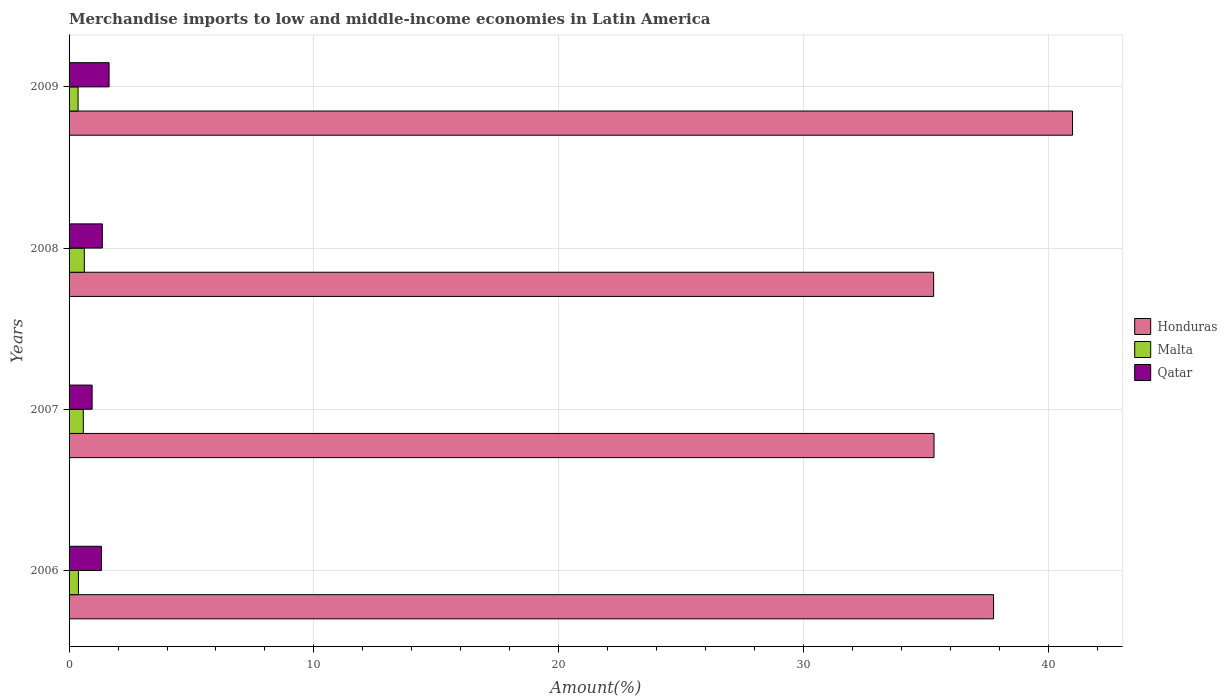How many different coloured bars are there?
Offer a terse response. 3. How many groups of bars are there?
Keep it short and to the point. 4. Are the number of bars per tick equal to the number of legend labels?
Keep it short and to the point. Yes. Are the number of bars on each tick of the Y-axis equal?
Provide a succinct answer. Yes. How many bars are there on the 3rd tick from the top?
Your answer should be very brief. 3. How many bars are there on the 3rd tick from the bottom?
Provide a short and direct response. 3. In how many cases, is the number of bars for a given year not equal to the number of legend labels?
Make the answer very short. 0. What is the percentage of amount earned from merchandise imports in Honduras in 2009?
Your answer should be very brief. 40.98. Across all years, what is the maximum percentage of amount earned from merchandise imports in Qatar?
Ensure brevity in your answer.  1.63. Across all years, what is the minimum percentage of amount earned from merchandise imports in Qatar?
Your response must be concise. 0.94. In which year was the percentage of amount earned from merchandise imports in Malta maximum?
Offer a terse response. 2008. In which year was the percentage of amount earned from merchandise imports in Qatar minimum?
Your answer should be very brief. 2007. What is the total percentage of amount earned from merchandise imports in Honduras in the graph?
Your answer should be very brief. 149.37. What is the difference between the percentage of amount earned from merchandise imports in Malta in 2007 and that in 2009?
Your response must be concise. 0.21. What is the difference between the percentage of amount earned from merchandise imports in Honduras in 2006 and the percentage of amount earned from merchandise imports in Malta in 2009?
Offer a terse response. 37.39. What is the average percentage of amount earned from merchandise imports in Qatar per year?
Your answer should be very brief. 1.31. In the year 2007, what is the difference between the percentage of amount earned from merchandise imports in Honduras and percentage of amount earned from merchandise imports in Qatar?
Offer a terse response. 34.38. In how many years, is the percentage of amount earned from merchandise imports in Malta greater than 26 %?
Ensure brevity in your answer.  0. What is the ratio of the percentage of amount earned from merchandise imports in Honduras in 2006 to that in 2007?
Provide a succinct answer. 1.07. What is the difference between the highest and the second highest percentage of amount earned from merchandise imports in Honduras?
Provide a short and direct response. 3.22. What is the difference between the highest and the lowest percentage of amount earned from merchandise imports in Malta?
Provide a short and direct response. 0.26. In how many years, is the percentage of amount earned from merchandise imports in Qatar greater than the average percentage of amount earned from merchandise imports in Qatar taken over all years?
Your response must be concise. 3. What does the 3rd bar from the top in 2006 represents?
Provide a succinct answer. Honduras. What does the 1st bar from the bottom in 2007 represents?
Provide a short and direct response. Honduras. How many years are there in the graph?
Provide a short and direct response. 4. Does the graph contain grids?
Ensure brevity in your answer.  Yes. Where does the legend appear in the graph?
Make the answer very short. Center right. What is the title of the graph?
Provide a short and direct response. Merchandise imports to low and middle-income economies in Latin America. Does "United States" appear as one of the legend labels in the graph?
Your answer should be compact. No. What is the label or title of the X-axis?
Offer a terse response. Amount(%). What is the Amount(%) of Honduras in 2006?
Ensure brevity in your answer.  37.76. What is the Amount(%) of Malta in 2006?
Your response must be concise. 0.38. What is the Amount(%) of Qatar in 2006?
Your answer should be very brief. 1.32. What is the Amount(%) in Honduras in 2007?
Ensure brevity in your answer.  35.32. What is the Amount(%) in Malta in 2007?
Your answer should be very brief. 0.58. What is the Amount(%) of Qatar in 2007?
Give a very brief answer. 0.94. What is the Amount(%) of Honduras in 2008?
Provide a succinct answer. 35.31. What is the Amount(%) in Malta in 2008?
Give a very brief answer. 0.62. What is the Amount(%) of Qatar in 2008?
Give a very brief answer. 1.36. What is the Amount(%) of Honduras in 2009?
Your response must be concise. 40.98. What is the Amount(%) of Malta in 2009?
Keep it short and to the point. 0.37. What is the Amount(%) in Qatar in 2009?
Give a very brief answer. 1.63. Across all years, what is the maximum Amount(%) in Honduras?
Offer a very short reply. 40.98. Across all years, what is the maximum Amount(%) of Malta?
Your response must be concise. 0.62. Across all years, what is the maximum Amount(%) in Qatar?
Give a very brief answer. 1.63. Across all years, what is the minimum Amount(%) in Honduras?
Your answer should be compact. 35.31. Across all years, what is the minimum Amount(%) of Malta?
Offer a very short reply. 0.37. Across all years, what is the minimum Amount(%) of Qatar?
Offer a terse response. 0.94. What is the total Amount(%) of Honduras in the graph?
Give a very brief answer. 149.37. What is the total Amount(%) in Malta in the graph?
Provide a short and direct response. 1.95. What is the total Amount(%) in Qatar in the graph?
Provide a short and direct response. 5.26. What is the difference between the Amount(%) in Honduras in 2006 and that in 2007?
Offer a very short reply. 2.43. What is the difference between the Amount(%) in Malta in 2006 and that in 2007?
Ensure brevity in your answer.  -0.2. What is the difference between the Amount(%) in Qatar in 2006 and that in 2007?
Make the answer very short. 0.38. What is the difference between the Amount(%) of Honduras in 2006 and that in 2008?
Your answer should be compact. 2.45. What is the difference between the Amount(%) in Malta in 2006 and that in 2008?
Your answer should be very brief. -0.24. What is the difference between the Amount(%) in Qatar in 2006 and that in 2008?
Your answer should be very brief. -0.04. What is the difference between the Amount(%) in Honduras in 2006 and that in 2009?
Your response must be concise. -3.22. What is the difference between the Amount(%) of Malta in 2006 and that in 2009?
Your answer should be very brief. 0.01. What is the difference between the Amount(%) of Qatar in 2006 and that in 2009?
Make the answer very short. -0.31. What is the difference between the Amount(%) in Honduras in 2007 and that in 2008?
Your answer should be compact. 0.02. What is the difference between the Amount(%) of Malta in 2007 and that in 2008?
Provide a short and direct response. -0.04. What is the difference between the Amount(%) in Qatar in 2007 and that in 2008?
Keep it short and to the point. -0.42. What is the difference between the Amount(%) of Honduras in 2007 and that in 2009?
Your answer should be compact. -5.66. What is the difference between the Amount(%) of Malta in 2007 and that in 2009?
Provide a short and direct response. 0.21. What is the difference between the Amount(%) of Qatar in 2007 and that in 2009?
Your answer should be compact. -0.69. What is the difference between the Amount(%) in Honduras in 2008 and that in 2009?
Your answer should be very brief. -5.67. What is the difference between the Amount(%) in Malta in 2008 and that in 2009?
Provide a short and direct response. 0.26. What is the difference between the Amount(%) of Qatar in 2008 and that in 2009?
Give a very brief answer. -0.28. What is the difference between the Amount(%) in Honduras in 2006 and the Amount(%) in Malta in 2007?
Give a very brief answer. 37.17. What is the difference between the Amount(%) in Honduras in 2006 and the Amount(%) in Qatar in 2007?
Your response must be concise. 36.81. What is the difference between the Amount(%) of Malta in 2006 and the Amount(%) of Qatar in 2007?
Keep it short and to the point. -0.56. What is the difference between the Amount(%) of Honduras in 2006 and the Amount(%) of Malta in 2008?
Offer a terse response. 37.13. What is the difference between the Amount(%) in Honduras in 2006 and the Amount(%) in Qatar in 2008?
Offer a very short reply. 36.4. What is the difference between the Amount(%) in Malta in 2006 and the Amount(%) in Qatar in 2008?
Ensure brevity in your answer.  -0.98. What is the difference between the Amount(%) of Honduras in 2006 and the Amount(%) of Malta in 2009?
Provide a succinct answer. 37.39. What is the difference between the Amount(%) in Honduras in 2006 and the Amount(%) in Qatar in 2009?
Offer a terse response. 36.12. What is the difference between the Amount(%) of Malta in 2006 and the Amount(%) of Qatar in 2009?
Ensure brevity in your answer.  -1.25. What is the difference between the Amount(%) in Honduras in 2007 and the Amount(%) in Malta in 2008?
Offer a very short reply. 34.7. What is the difference between the Amount(%) in Honduras in 2007 and the Amount(%) in Qatar in 2008?
Provide a succinct answer. 33.97. What is the difference between the Amount(%) in Malta in 2007 and the Amount(%) in Qatar in 2008?
Your answer should be very brief. -0.78. What is the difference between the Amount(%) of Honduras in 2007 and the Amount(%) of Malta in 2009?
Your answer should be compact. 34.96. What is the difference between the Amount(%) in Honduras in 2007 and the Amount(%) in Qatar in 2009?
Make the answer very short. 33.69. What is the difference between the Amount(%) in Malta in 2007 and the Amount(%) in Qatar in 2009?
Your response must be concise. -1.05. What is the difference between the Amount(%) of Honduras in 2008 and the Amount(%) of Malta in 2009?
Offer a terse response. 34.94. What is the difference between the Amount(%) of Honduras in 2008 and the Amount(%) of Qatar in 2009?
Provide a succinct answer. 33.67. What is the difference between the Amount(%) in Malta in 2008 and the Amount(%) in Qatar in 2009?
Offer a terse response. -1.01. What is the average Amount(%) in Honduras per year?
Keep it short and to the point. 37.34. What is the average Amount(%) of Malta per year?
Your response must be concise. 0.49. What is the average Amount(%) in Qatar per year?
Offer a very short reply. 1.31. In the year 2006, what is the difference between the Amount(%) in Honduras and Amount(%) in Malta?
Keep it short and to the point. 37.37. In the year 2006, what is the difference between the Amount(%) in Honduras and Amount(%) in Qatar?
Give a very brief answer. 36.43. In the year 2006, what is the difference between the Amount(%) in Malta and Amount(%) in Qatar?
Your answer should be compact. -0.94. In the year 2007, what is the difference between the Amount(%) in Honduras and Amount(%) in Malta?
Ensure brevity in your answer.  34.74. In the year 2007, what is the difference between the Amount(%) of Honduras and Amount(%) of Qatar?
Give a very brief answer. 34.38. In the year 2007, what is the difference between the Amount(%) in Malta and Amount(%) in Qatar?
Offer a terse response. -0.36. In the year 2008, what is the difference between the Amount(%) of Honduras and Amount(%) of Malta?
Keep it short and to the point. 34.69. In the year 2008, what is the difference between the Amount(%) in Honduras and Amount(%) in Qatar?
Your answer should be very brief. 33.95. In the year 2008, what is the difference between the Amount(%) of Malta and Amount(%) of Qatar?
Provide a succinct answer. -0.74. In the year 2009, what is the difference between the Amount(%) in Honduras and Amount(%) in Malta?
Your answer should be very brief. 40.61. In the year 2009, what is the difference between the Amount(%) of Honduras and Amount(%) of Qatar?
Make the answer very short. 39.35. In the year 2009, what is the difference between the Amount(%) of Malta and Amount(%) of Qatar?
Keep it short and to the point. -1.27. What is the ratio of the Amount(%) of Honduras in 2006 to that in 2007?
Offer a terse response. 1.07. What is the ratio of the Amount(%) in Malta in 2006 to that in 2007?
Provide a succinct answer. 0.66. What is the ratio of the Amount(%) of Qatar in 2006 to that in 2007?
Keep it short and to the point. 1.4. What is the ratio of the Amount(%) in Honduras in 2006 to that in 2008?
Keep it short and to the point. 1.07. What is the ratio of the Amount(%) of Malta in 2006 to that in 2008?
Give a very brief answer. 0.61. What is the ratio of the Amount(%) of Qatar in 2006 to that in 2008?
Keep it short and to the point. 0.97. What is the ratio of the Amount(%) of Honduras in 2006 to that in 2009?
Provide a succinct answer. 0.92. What is the ratio of the Amount(%) of Malta in 2006 to that in 2009?
Your response must be concise. 1.04. What is the ratio of the Amount(%) in Qatar in 2006 to that in 2009?
Your answer should be very brief. 0.81. What is the ratio of the Amount(%) of Honduras in 2007 to that in 2008?
Offer a very short reply. 1. What is the ratio of the Amount(%) in Malta in 2007 to that in 2008?
Your answer should be very brief. 0.93. What is the ratio of the Amount(%) in Qatar in 2007 to that in 2008?
Provide a succinct answer. 0.69. What is the ratio of the Amount(%) in Honduras in 2007 to that in 2009?
Keep it short and to the point. 0.86. What is the ratio of the Amount(%) of Malta in 2007 to that in 2009?
Your answer should be very brief. 1.58. What is the ratio of the Amount(%) of Qatar in 2007 to that in 2009?
Your response must be concise. 0.58. What is the ratio of the Amount(%) in Honduras in 2008 to that in 2009?
Provide a short and direct response. 0.86. What is the ratio of the Amount(%) in Malta in 2008 to that in 2009?
Make the answer very short. 1.69. What is the ratio of the Amount(%) in Qatar in 2008 to that in 2009?
Provide a succinct answer. 0.83. What is the difference between the highest and the second highest Amount(%) in Honduras?
Your answer should be compact. 3.22. What is the difference between the highest and the second highest Amount(%) in Malta?
Provide a succinct answer. 0.04. What is the difference between the highest and the second highest Amount(%) of Qatar?
Ensure brevity in your answer.  0.28. What is the difference between the highest and the lowest Amount(%) of Honduras?
Provide a short and direct response. 5.67. What is the difference between the highest and the lowest Amount(%) of Malta?
Your answer should be very brief. 0.26. What is the difference between the highest and the lowest Amount(%) in Qatar?
Your answer should be compact. 0.69. 